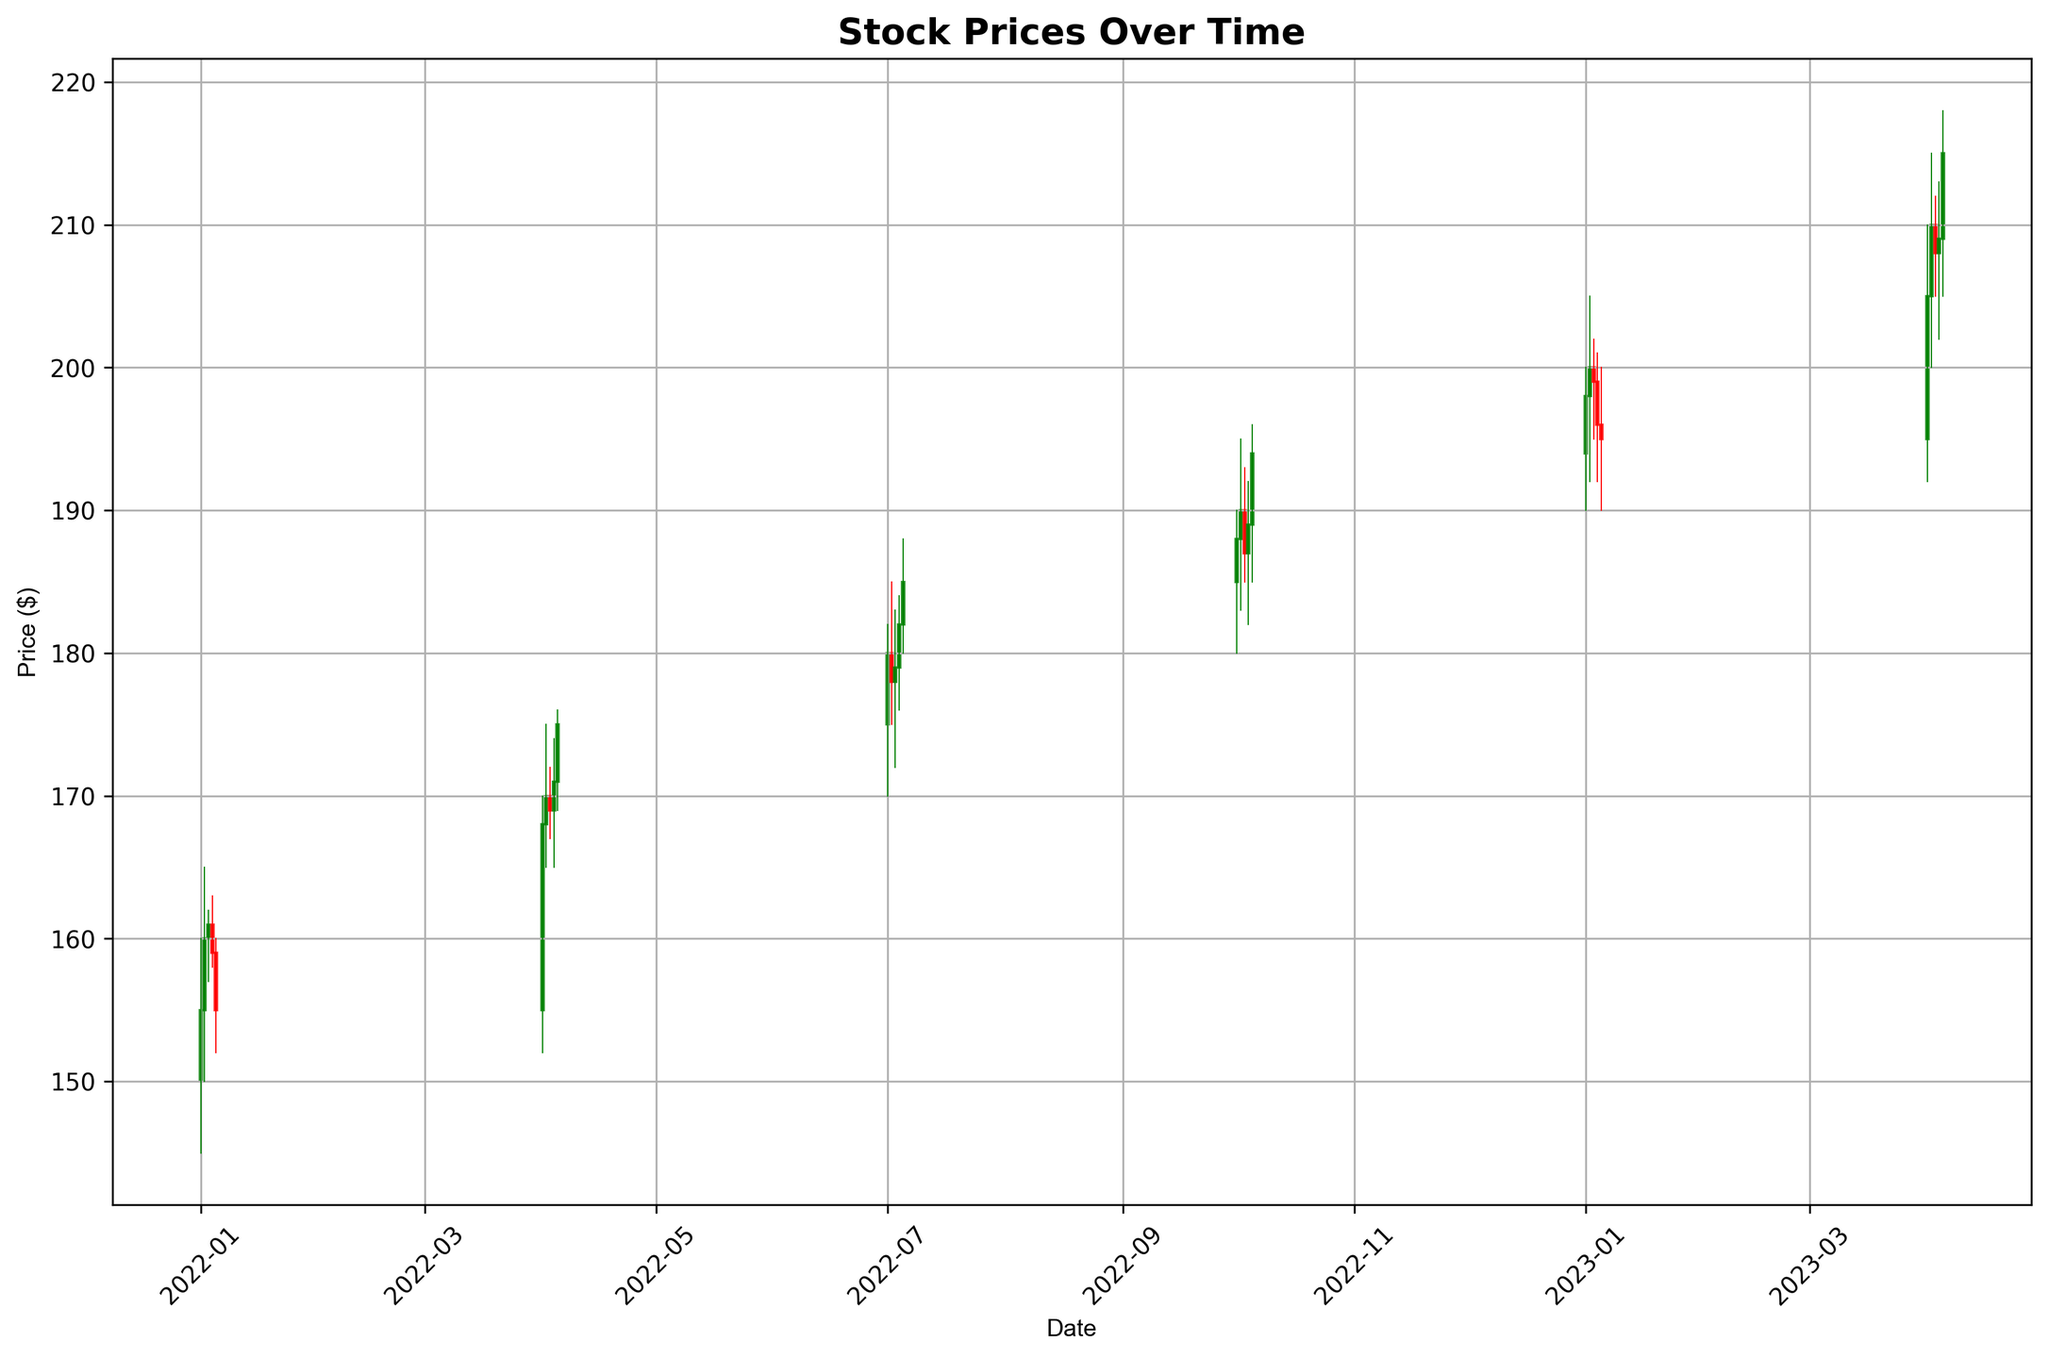What is the overall trend in stock prices over the given period? By examining the plot, we observe the stock prices from January 2022 to April 2023. The initial stock price is around $155, and it ends at around $215, showing a general upward trend.
Answer: Upward How does the stock price change after each quarterly product release? The plot includes specific dates marking quarterly product releases (Jan 1, Apr 1, Jul 1, and Oct 1 of 2022, and Jan 1 and Apr 1 of 2023). The stock price typically increases after each release. For instance, on Jan 1, 2022, the price increases from $155 to $160. Similar trends can be identified around other quarterly release dates.
Answer: Typically increases What is the highest stock price observed in the given period? By observing the candlestick chart, we see the highest price point near April 2023, where the stock price reaches approximately $218.
Answer: $218 Compare the stock prices before and after the July 2022 product release. How much did it change? Before the July 2022 product release (July 1), the stock price was about $175. After the release, it reached around $180. The change in stock price is $180 - $175.
Answer: $5 What is the average closing price for the four quarterly releases in 2022? To find this, we average the closing prices on the four quarterly release dates:
- Jan 1, 2022: $155
- Apr 1, 2022: $168
- Jul 1, 2022: $180
- Oct 1, 2022: $188
Average = (155 + 168 + 180 + 188) / 4
Answer: $172.75 Which quarter shows the most significant change in stock price? By examining the length of the candlesticks around each quarterly release:
- The Apr 2023 release shows a notable increase, with the stock price moving from approximately $195 to $215, indicating a significant change.
Answer: Apr 2023 How does the stock volume change throughout the period? The plot indicates that stock volume increases steadily over time, starting at 1,000,000 shares and reaching up to 3,900,000 shares by Apr 2023.
Answer: Increases steadily How many times did the stock price decrease following a quarterly product release in the given year? By observing the plot, it's clear that the stock price rarely decreases after a release. A detailed look shows that the stock price slightly decreases only once after the Jan 2023 release when it starts to decline from $198 to $195 within the following days.
Answer: Once What is the largest drop in stock price observed within a single day and when did it occur? By closely examining the candlestick lengths, the largest drop seems to be around Jan 5, 2022, where the stock dropped from $160 to $152, an $8 decrease.
Answer: $8 on Jan 5, 2022 